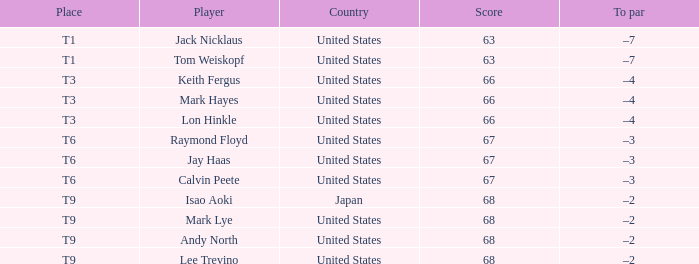What is the total number of Score, when Country is "United States", and when Player is "Lee Trevino"? 1.0. 